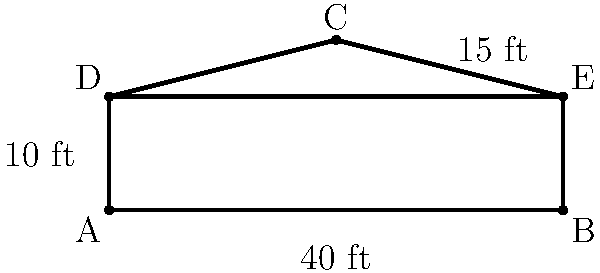At the North Texas Agricultural College's historical farm, a restored barn has a cross-section as shown in the diagram. The base of the barn is 40 feet wide and 10 feet high, with a triangular roof reaching an additional 5 feet at its peak. What is the total area of this cross-section in square feet? To find the total area of the barn's cross-section, we need to calculate the area of the rectangular base and the triangular roof, then add them together.

1. Area of the rectangular base:
   $$ A_{rectangle} = width \times height = 40 \text{ ft} \times 10 \text{ ft} = 400 \text{ sq ft} $$

2. Area of the triangular roof:
   The base of the triangle is the same as the width of the barn (40 ft), and its height is 5 ft.
   $$ A_{triangle} = \frac{1}{2} \times base \times height = \frac{1}{2} \times 40 \text{ ft} \times 5 \text{ ft} = 100 \text{ sq ft} $$

3. Total area:
   $$ A_{total} = A_{rectangle} + A_{triangle} = 400 \text{ sq ft} + 100 \text{ sq ft} = 500 \text{ sq ft} $$

Therefore, the total area of the barn's cross-section is 500 square feet.
Answer: 500 sq ft 